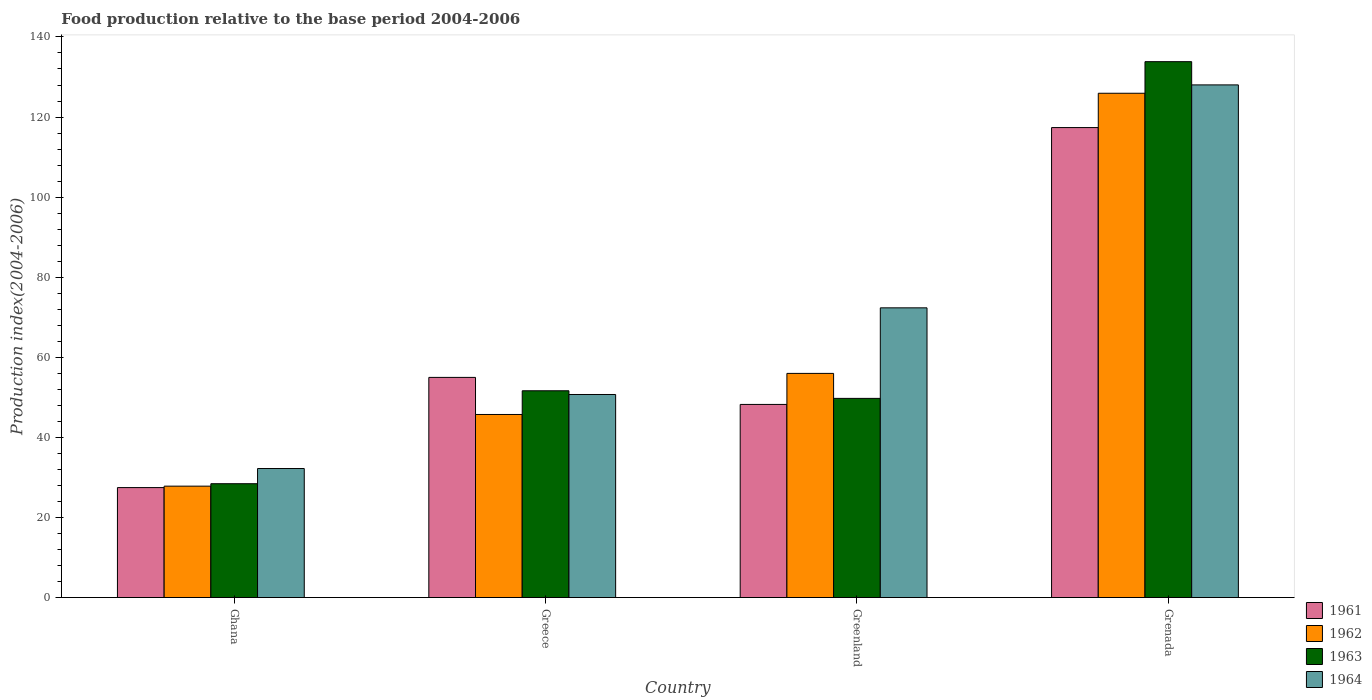How many different coloured bars are there?
Provide a short and direct response. 4. How many bars are there on the 2nd tick from the right?
Your response must be concise. 4. What is the label of the 1st group of bars from the left?
Provide a succinct answer. Ghana. What is the food production index in 1964 in Grenada?
Provide a succinct answer. 128.03. Across all countries, what is the maximum food production index in 1964?
Make the answer very short. 128.03. Across all countries, what is the minimum food production index in 1961?
Offer a very short reply. 27.46. In which country was the food production index in 1961 maximum?
Offer a terse response. Grenada. In which country was the food production index in 1963 minimum?
Offer a very short reply. Ghana. What is the total food production index in 1964 in the graph?
Offer a terse response. 283.31. What is the difference between the food production index in 1964 in Ghana and that in Greenland?
Offer a terse response. -40.13. What is the difference between the food production index in 1963 in Greece and the food production index in 1962 in Greenland?
Ensure brevity in your answer.  -4.34. What is the average food production index in 1962 per country?
Offer a very short reply. 63.86. What is the difference between the food production index of/in 1962 and food production index of/in 1963 in Greenland?
Your answer should be compact. 6.24. In how many countries, is the food production index in 1962 greater than 36?
Make the answer very short. 3. What is the ratio of the food production index in 1961 in Ghana to that in Grenada?
Your answer should be very brief. 0.23. Is the difference between the food production index in 1962 in Greece and Grenada greater than the difference between the food production index in 1963 in Greece and Grenada?
Offer a very short reply. Yes. What is the difference between the highest and the second highest food production index in 1963?
Your response must be concise. -1.9. What is the difference between the highest and the lowest food production index in 1962?
Give a very brief answer. 98.12. Is the sum of the food production index in 1962 in Ghana and Greece greater than the maximum food production index in 1963 across all countries?
Ensure brevity in your answer.  No. Is it the case that in every country, the sum of the food production index in 1963 and food production index in 1964 is greater than the sum of food production index in 1961 and food production index in 1962?
Your answer should be very brief. No. What does the 4th bar from the left in Grenada represents?
Provide a short and direct response. 1964. Is it the case that in every country, the sum of the food production index in 1962 and food production index in 1961 is greater than the food production index in 1963?
Give a very brief answer. Yes. How many bars are there?
Keep it short and to the point. 16. Are all the bars in the graph horizontal?
Your answer should be very brief. No. How many countries are there in the graph?
Make the answer very short. 4. What is the difference between two consecutive major ticks on the Y-axis?
Make the answer very short. 20. Are the values on the major ticks of Y-axis written in scientific E-notation?
Provide a short and direct response. No. Does the graph contain grids?
Offer a terse response. No. Where does the legend appear in the graph?
Your answer should be compact. Bottom right. What is the title of the graph?
Your answer should be compact. Food production relative to the base period 2004-2006. Does "2008" appear as one of the legend labels in the graph?
Offer a very short reply. No. What is the label or title of the X-axis?
Provide a succinct answer. Country. What is the label or title of the Y-axis?
Ensure brevity in your answer.  Production index(2004-2006). What is the Production index(2004-2006) of 1961 in Ghana?
Ensure brevity in your answer.  27.46. What is the Production index(2004-2006) of 1962 in Ghana?
Your answer should be compact. 27.82. What is the Production index(2004-2006) of 1963 in Ghana?
Offer a very short reply. 28.43. What is the Production index(2004-2006) in 1964 in Ghana?
Offer a very short reply. 32.22. What is the Production index(2004-2006) of 1961 in Greece?
Your answer should be very brief. 54.98. What is the Production index(2004-2006) in 1962 in Greece?
Provide a short and direct response. 45.72. What is the Production index(2004-2006) in 1963 in Greece?
Ensure brevity in your answer.  51.64. What is the Production index(2004-2006) in 1964 in Greece?
Provide a succinct answer. 50.71. What is the Production index(2004-2006) in 1961 in Greenland?
Make the answer very short. 48.23. What is the Production index(2004-2006) of 1962 in Greenland?
Keep it short and to the point. 55.98. What is the Production index(2004-2006) of 1963 in Greenland?
Offer a very short reply. 49.74. What is the Production index(2004-2006) in 1964 in Greenland?
Offer a terse response. 72.35. What is the Production index(2004-2006) of 1961 in Grenada?
Your answer should be very brief. 117.37. What is the Production index(2004-2006) in 1962 in Grenada?
Your answer should be very brief. 125.94. What is the Production index(2004-2006) in 1963 in Grenada?
Make the answer very short. 133.83. What is the Production index(2004-2006) of 1964 in Grenada?
Keep it short and to the point. 128.03. Across all countries, what is the maximum Production index(2004-2006) in 1961?
Provide a succinct answer. 117.37. Across all countries, what is the maximum Production index(2004-2006) in 1962?
Make the answer very short. 125.94. Across all countries, what is the maximum Production index(2004-2006) of 1963?
Offer a terse response. 133.83. Across all countries, what is the maximum Production index(2004-2006) of 1964?
Provide a short and direct response. 128.03. Across all countries, what is the minimum Production index(2004-2006) in 1961?
Make the answer very short. 27.46. Across all countries, what is the minimum Production index(2004-2006) in 1962?
Offer a very short reply. 27.82. Across all countries, what is the minimum Production index(2004-2006) of 1963?
Your answer should be compact. 28.43. Across all countries, what is the minimum Production index(2004-2006) in 1964?
Make the answer very short. 32.22. What is the total Production index(2004-2006) in 1961 in the graph?
Keep it short and to the point. 248.04. What is the total Production index(2004-2006) in 1962 in the graph?
Give a very brief answer. 255.46. What is the total Production index(2004-2006) in 1963 in the graph?
Offer a terse response. 263.64. What is the total Production index(2004-2006) in 1964 in the graph?
Provide a short and direct response. 283.31. What is the difference between the Production index(2004-2006) of 1961 in Ghana and that in Greece?
Ensure brevity in your answer.  -27.52. What is the difference between the Production index(2004-2006) of 1962 in Ghana and that in Greece?
Your response must be concise. -17.9. What is the difference between the Production index(2004-2006) of 1963 in Ghana and that in Greece?
Provide a short and direct response. -23.21. What is the difference between the Production index(2004-2006) of 1964 in Ghana and that in Greece?
Keep it short and to the point. -18.49. What is the difference between the Production index(2004-2006) in 1961 in Ghana and that in Greenland?
Offer a very short reply. -20.77. What is the difference between the Production index(2004-2006) in 1962 in Ghana and that in Greenland?
Offer a terse response. -28.16. What is the difference between the Production index(2004-2006) of 1963 in Ghana and that in Greenland?
Keep it short and to the point. -21.31. What is the difference between the Production index(2004-2006) of 1964 in Ghana and that in Greenland?
Make the answer very short. -40.13. What is the difference between the Production index(2004-2006) in 1961 in Ghana and that in Grenada?
Offer a terse response. -89.91. What is the difference between the Production index(2004-2006) in 1962 in Ghana and that in Grenada?
Ensure brevity in your answer.  -98.12. What is the difference between the Production index(2004-2006) in 1963 in Ghana and that in Grenada?
Ensure brevity in your answer.  -105.4. What is the difference between the Production index(2004-2006) in 1964 in Ghana and that in Grenada?
Your response must be concise. -95.81. What is the difference between the Production index(2004-2006) of 1961 in Greece and that in Greenland?
Your response must be concise. 6.75. What is the difference between the Production index(2004-2006) in 1962 in Greece and that in Greenland?
Keep it short and to the point. -10.26. What is the difference between the Production index(2004-2006) of 1964 in Greece and that in Greenland?
Keep it short and to the point. -21.64. What is the difference between the Production index(2004-2006) in 1961 in Greece and that in Grenada?
Keep it short and to the point. -62.39. What is the difference between the Production index(2004-2006) of 1962 in Greece and that in Grenada?
Keep it short and to the point. -80.22. What is the difference between the Production index(2004-2006) of 1963 in Greece and that in Grenada?
Make the answer very short. -82.19. What is the difference between the Production index(2004-2006) of 1964 in Greece and that in Grenada?
Ensure brevity in your answer.  -77.32. What is the difference between the Production index(2004-2006) in 1961 in Greenland and that in Grenada?
Your answer should be compact. -69.14. What is the difference between the Production index(2004-2006) of 1962 in Greenland and that in Grenada?
Your answer should be compact. -69.96. What is the difference between the Production index(2004-2006) of 1963 in Greenland and that in Grenada?
Offer a terse response. -84.09. What is the difference between the Production index(2004-2006) in 1964 in Greenland and that in Grenada?
Provide a short and direct response. -55.68. What is the difference between the Production index(2004-2006) of 1961 in Ghana and the Production index(2004-2006) of 1962 in Greece?
Provide a succinct answer. -18.26. What is the difference between the Production index(2004-2006) of 1961 in Ghana and the Production index(2004-2006) of 1963 in Greece?
Provide a succinct answer. -24.18. What is the difference between the Production index(2004-2006) of 1961 in Ghana and the Production index(2004-2006) of 1964 in Greece?
Provide a succinct answer. -23.25. What is the difference between the Production index(2004-2006) of 1962 in Ghana and the Production index(2004-2006) of 1963 in Greece?
Offer a very short reply. -23.82. What is the difference between the Production index(2004-2006) of 1962 in Ghana and the Production index(2004-2006) of 1964 in Greece?
Offer a terse response. -22.89. What is the difference between the Production index(2004-2006) in 1963 in Ghana and the Production index(2004-2006) in 1964 in Greece?
Your answer should be compact. -22.28. What is the difference between the Production index(2004-2006) of 1961 in Ghana and the Production index(2004-2006) of 1962 in Greenland?
Offer a very short reply. -28.52. What is the difference between the Production index(2004-2006) in 1961 in Ghana and the Production index(2004-2006) in 1963 in Greenland?
Provide a succinct answer. -22.28. What is the difference between the Production index(2004-2006) of 1961 in Ghana and the Production index(2004-2006) of 1964 in Greenland?
Provide a succinct answer. -44.89. What is the difference between the Production index(2004-2006) in 1962 in Ghana and the Production index(2004-2006) in 1963 in Greenland?
Your answer should be very brief. -21.92. What is the difference between the Production index(2004-2006) in 1962 in Ghana and the Production index(2004-2006) in 1964 in Greenland?
Provide a succinct answer. -44.53. What is the difference between the Production index(2004-2006) of 1963 in Ghana and the Production index(2004-2006) of 1964 in Greenland?
Provide a short and direct response. -43.92. What is the difference between the Production index(2004-2006) of 1961 in Ghana and the Production index(2004-2006) of 1962 in Grenada?
Your answer should be very brief. -98.48. What is the difference between the Production index(2004-2006) in 1961 in Ghana and the Production index(2004-2006) in 1963 in Grenada?
Give a very brief answer. -106.37. What is the difference between the Production index(2004-2006) in 1961 in Ghana and the Production index(2004-2006) in 1964 in Grenada?
Offer a very short reply. -100.57. What is the difference between the Production index(2004-2006) of 1962 in Ghana and the Production index(2004-2006) of 1963 in Grenada?
Your response must be concise. -106.01. What is the difference between the Production index(2004-2006) of 1962 in Ghana and the Production index(2004-2006) of 1964 in Grenada?
Ensure brevity in your answer.  -100.21. What is the difference between the Production index(2004-2006) in 1963 in Ghana and the Production index(2004-2006) in 1964 in Grenada?
Provide a short and direct response. -99.6. What is the difference between the Production index(2004-2006) of 1961 in Greece and the Production index(2004-2006) of 1962 in Greenland?
Ensure brevity in your answer.  -1. What is the difference between the Production index(2004-2006) of 1961 in Greece and the Production index(2004-2006) of 1963 in Greenland?
Your answer should be compact. 5.24. What is the difference between the Production index(2004-2006) in 1961 in Greece and the Production index(2004-2006) in 1964 in Greenland?
Provide a short and direct response. -17.37. What is the difference between the Production index(2004-2006) in 1962 in Greece and the Production index(2004-2006) in 1963 in Greenland?
Keep it short and to the point. -4.02. What is the difference between the Production index(2004-2006) in 1962 in Greece and the Production index(2004-2006) in 1964 in Greenland?
Your response must be concise. -26.63. What is the difference between the Production index(2004-2006) of 1963 in Greece and the Production index(2004-2006) of 1964 in Greenland?
Ensure brevity in your answer.  -20.71. What is the difference between the Production index(2004-2006) of 1961 in Greece and the Production index(2004-2006) of 1962 in Grenada?
Keep it short and to the point. -70.96. What is the difference between the Production index(2004-2006) in 1961 in Greece and the Production index(2004-2006) in 1963 in Grenada?
Your answer should be compact. -78.85. What is the difference between the Production index(2004-2006) in 1961 in Greece and the Production index(2004-2006) in 1964 in Grenada?
Your answer should be compact. -73.05. What is the difference between the Production index(2004-2006) of 1962 in Greece and the Production index(2004-2006) of 1963 in Grenada?
Offer a terse response. -88.11. What is the difference between the Production index(2004-2006) in 1962 in Greece and the Production index(2004-2006) in 1964 in Grenada?
Provide a succinct answer. -82.31. What is the difference between the Production index(2004-2006) of 1963 in Greece and the Production index(2004-2006) of 1964 in Grenada?
Provide a short and direct response. -76.39. What is the difference between the Production index(2004-2006) in 1961 in Greenland and the Production index(2004-2006) in 1962 in Grenada?
Make the answer very short. -77.71. What is the difference between the Production index(2004-2006) in 1961 in Greenland and the Production index(2004-2006) in 1963 in Grenada?
Give a very brief answer. -85.6. What is the difference between the Production index(2004-2006) of 1961 in Greenland and the Production index(2004-2006) of 1964 in Grenada?
Ensure brevity in your answer.  -79.8. What is the difference between the Production index(2004-2006) of 1962 in Greenland and the Production index(2004-2006) of 1963 in Grenada?
Offer a terse response. -77.85. What is the difference between the Production index(2004-2006) of 1962 in Greenland and the Production index(2004-2006) of 1964 in Grenada?
Your answer should be very brief. -72.05. What is the difference between the Production index(2004-2006) of 1963 in Greenland and the Production index(2004-2006) of 1964 in Grenada?
Offer a very short reply. -78.29. What is the average Production index(2004-2006) of 1961 per country?
Your answer should be compact. 62.01. What is the average Production index(2004-2006) of 1962 per country?
Offer a terse response. 63.87. What is the average Production index(2004-2006) of 1963 per country?
Give a very brief answer. 65.91. What is the average Production index(2004-2006) of 1964 per country?
Your answer should be very brief. 70.83. What is the difference between the Production index(2004-2006) of 1961 and Production index(2004-2006) of 1962 in Ghana?
Ensure brevity in your answer.  -0.36. What is the difference between the Production index(2004-2006) of 1961 and Production index(2004-2006) of 1963 in Ghana?
Give a very brief answer. -0.97. What is the difference between the Production index(2004-2006) in 1961 and Production index(2004-2006) in 1964 in Ghana?
Ensure brevity in your answer.  -4.76. What is the difference between the Production index(2004-2006) in 1962 and Production index(2004-2006) in 1963 in Ghana?
Give a very brief answer. -0.61. What is the difference between the Production index(2004-2006) of 1962 and Production index(2004-2006) of 1964 in Ghana?
Give a very brief answer. -4.4. What is the difference between the Production index(2004-2006) of 1963 and Production index(2004-2006) of 1964 in Ghana?
Your response must be concise. -3.79. What is the difference between the Production index(2004-2006) in 1961 and Production index(2004-2006) in 1962 in Greece?
Ensure brevity in your answer.  9.26. What is the difference between the Production index(2004-2006) of 1961 and Production index(2004-2006) of 1963 in Greece?
Your answer should be very brief. 3.34. What is the difference between the Production index(2004-2006) in 1961 and Production index(2004-2006) in 1964 in Greece?
Offer a very short reply. 4.27. What is the difference between the Production index(2004-2006) of 1962 and Production index(2004-2006) of 1963 in Greece?
Make the answer very short. -5.92. What is the difference between the Production index(2004-2006) in 1962 and Production index(2004-2006) in 1964 in Greece?
Your answer should be very brief. -4.99. What is the difference between the Production index(2004-2006) of 1963 and Production index(2004-2006) of 1964 in Greece?
Offer a very short reply. 0.93. What is the difference between the Production index(2004-2006) of 1961 and Production index(2004-2006) of 1962 in Greenland?
Provide a short and direct response. -7.75. What is the difference between the Production index(2004-2006) of 1961 and Production index(2004-2006) of 1963 in Greenland?
Offer a terse response. -1.51. What is the difference between the Production index(2004-2006) in 1961 and Production index(2004-2006) in 1964 in Greenland?
Provide a short and direct response. -24.12. What is the difference between the Production index(2004-2006) of 1962 and Production index(2004-2006) of 1963 in Greenland?
Your answer should be compact. 6.24. What is the difference between the Production index(2004-2006) in 1962 and Production index(2004-2006) in 1964 in Greenland?
Provide a short and direct response. -16.37. What is the difference between the Production index(2004-2006) of 1963 and Production index(2004-2006) of 1964 in Greenland?
Provide a succinct answer. -22.61. What is the difference between the Production index(2004-2006) in 1961 and Production index(2004-2006) in 1962 in Grenada?
Your answer should be compact. -8.57. What is the difference between the Production index(2004-2006) of 1961 and Production index(2004-2006) of 1963 in Grenada?
Offer a terse response. -16.46. What is the difference between the Production index(2004-2006) in 1961 and Production index(2004-2006) in 1964 in Grenada?
Ensure brevity in your answer.  -10.66. What is the difference between the Production index(2004-2006) of 1962 and Production index(2004-2006) of 1963 in Grenada?
Your answer should be very brief. -7.89. What is the difference between the Production index(2004-2006) of 1962 and Production index(2004-2006) of 1964 in Grenada?
Keep it short and to the point. -2.09. What is the difference between the Production index(2004-2006) of 1963 and Production index(2004-2006) of 1964 in Grenada?
Give a very brief answer. 5.8. What is the ratio of the Production index(2004-2006) of 1961 in Ghana to that in Greece?
Ensure brevity in your answer.  0.5. What is the ratio of the Production index(2004-2006) in 1962 in Ghana to that in Greece?
Your response must be concise. 0.61. What is the ratio of the Production index(2004-2006) in 1963 in Ghana to that in Greece?
Offer a terse response. 0.55. What is the ratio of the Production index(2004-2006) of 1964 in Ghana to that in Greece?
Give a very brief answer. 0.64. What is the ratio of the Production index(2004-2006) of 1961 in Ghana to that in Greenland?
Your answer should be very brief. 0.57. What is the ratio of the Production index(2004-2006) in 1962 in Ghana to that in Greenland?
Make the answer very short. 0.5. What is the ratio of the Production index(2004-2006) of 1963 in Ghana to that in Greenland?
Your answer should be compact. 0.57. What is the ratio of the Production index(2004-2006) in 1964 in Ghana to that in Greenland?
Offer a terse response. 0.45. What is the ratio of the Production index(2004-2006) of 1961 in Ghana to that in Grenada?
Give a very brief answer. 0.23. What is the ratio of the Production index(2004-2006) in 1962 in Ghana to that in Grenada?
Your response must be concise. 0.22. What is the ratio of the Production index(2004-2006) of 1963 in Ghana to that in Grenada?
Provide a succinct answer. 0.21. What is the ratio of the Production index(2004-2006) of 1964 in Ghana to that in Grenada?
Ensure brevity in your answer.  0.25. What is the ratio of the Production index(2004-2006) in 1961 in Greece to that in Greenland?
Make the answer very short. 1.14. What is the ratio of the Production index(2004-2006) in 1962 in Greece to that in Greenland?
Ensure brevity in your answer.  0.82. What is the ratio of the Production index(2004-2006) in 1963 in Greece to that in Greenland?
Your answer should be compact. 1.04. What is the ratio of the Production index(2004-2006) in 1964 in Greece to that in Greenland?
Ensure brevity in your answer.  0.7. What is the ratio of the Production index(2004-2006) of 1961 in Greece to that in Grenada?
Offer a very short reply. 0.47. What is the ratio of the Production index(2004-2006) in 1962 in Greece to that in Grenada?
Keep it short and to the point. 0.36. What is the ratio of the Production index(2004-2006) of 1963 in Greece to that in Grenada?
Give a very brief answer. 0.39. What is the ratio of the Production index(2004-2006) of 1964 in Greece to that in Grenada?
Make the answer very short. 0.4. What is the ratio of the Production index(2004-2006) in 1961 in Greenland to that in Grenada?
Provide a succinct answer. 0.41. What is the ratio of the Production index(2004-2006) of 1962 in Greenland to that in Grenada?
Ensure brevity in your answer.  0.44. What is the ratio of the Production index(2004-2006) in 1963 in Greenland to that in Grenada?
Give a very brief answer. 0.37. What is the ratio of the Production index(2004-2006) in 1964 in Greenland to that in Grenada?
Keep it short and to the point. 0.57. What is the difference between the highest and the second highest Production index(2004-2006) in 1961?
Ensure brevity in your answer.  62.39. What is the difference between the highest and the second highest Production index(2004-2006) of 1962?
Provide a short and direct response. 69.96. What is the difference between the highest and the second highest Production index(2004-2006) in 1963?
Your answer should be compact. 82.19. What is the difference between the highest and the second highest Production index(2004-2006) of 1964?
Provide a succinct answer. 55.68. What is the difference between the highest and the lowest Production index(2004-2006) in 1961?
Your response must be concise. 89.91. What is the difference between the highest and the lowest Production index(2004-2006) of 1962?
Provide a short and direct response. 98.12. What is the difference between the highest and the lowest Production index(2004-2006) of 1963?
Your answer should be compact. 105.4. What is the difference between the highest and the lowest Production index(2004-2006) in 1964?
Give a very brief answer. 95.81. 